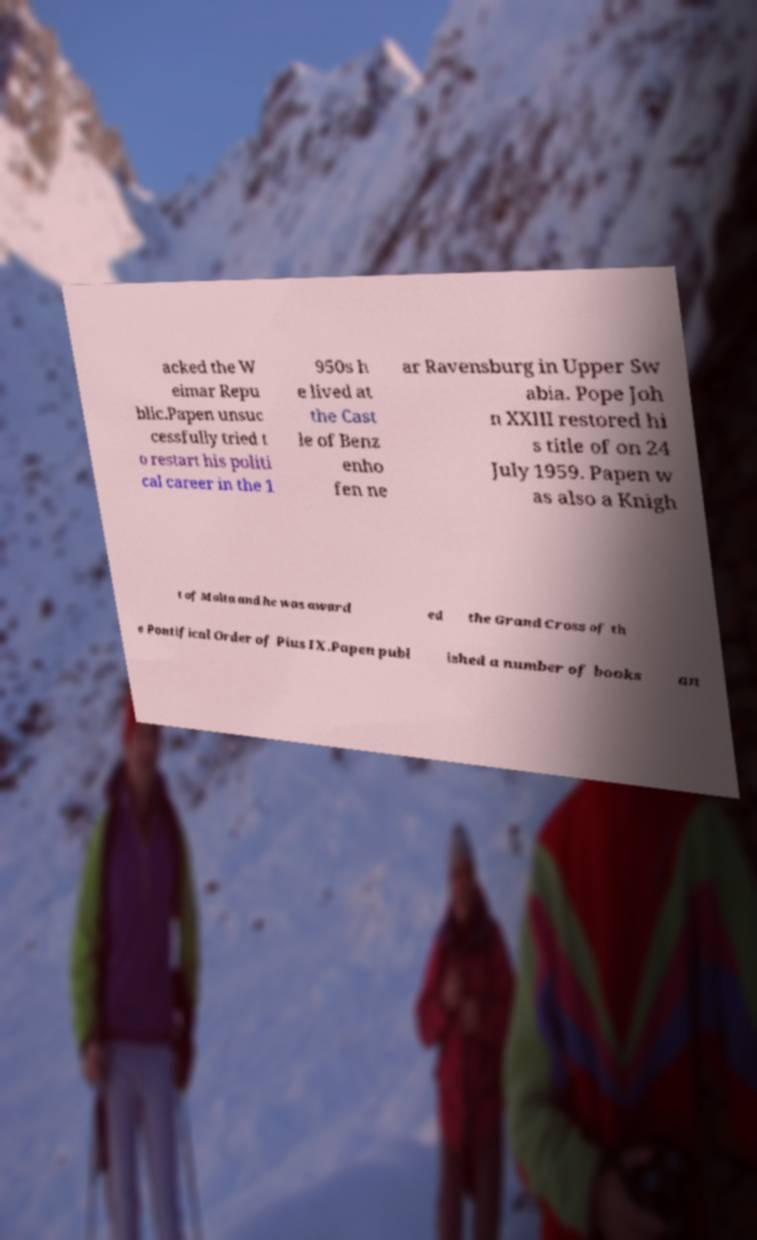Could you assist in decoding the text presented in this image and type it out clearly? acked the W eimar Repu blic.Papen unsuc cessfully tried t o restart his politi cal career in the 1 950s h e lived at the Cast le of Benz enho fen ne ar Ravensburg in Upper Sw abia. Pope Joh n XXIII restored hi s title of on 24 July 1959. Papen w as also a Knigh t of Malta and he was award ed the Grand Cross of th e Pontifical Order of Pius IX.Papen publ ished a number of books an 